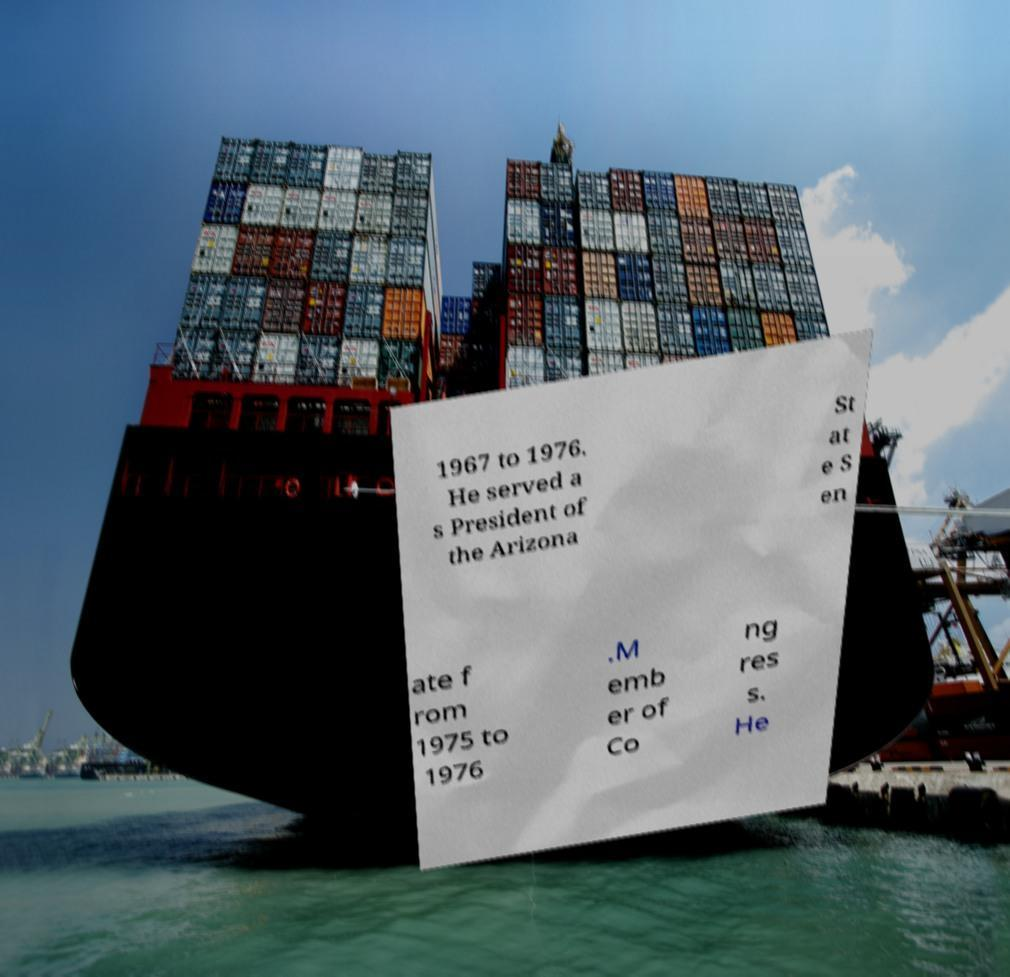There's text embedded in this image that I need extracted. Can you transcribe it verbatim? 1967 to 1976. He served a s President of the Arizona St at e S en ate f rom 1975 to 1976 .M emb er of Co ng res s. He 